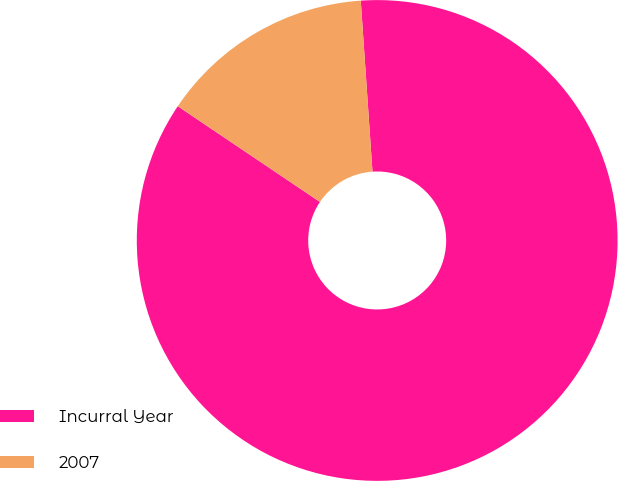Convert chart to OTSL. <chart><loc_0><loc_0><loc_500><loc_500><pie_chart><fcel>Incurral Year<fcel>2007<nl><fcel>85.52%<fcel>14.48%<nl></chart> 